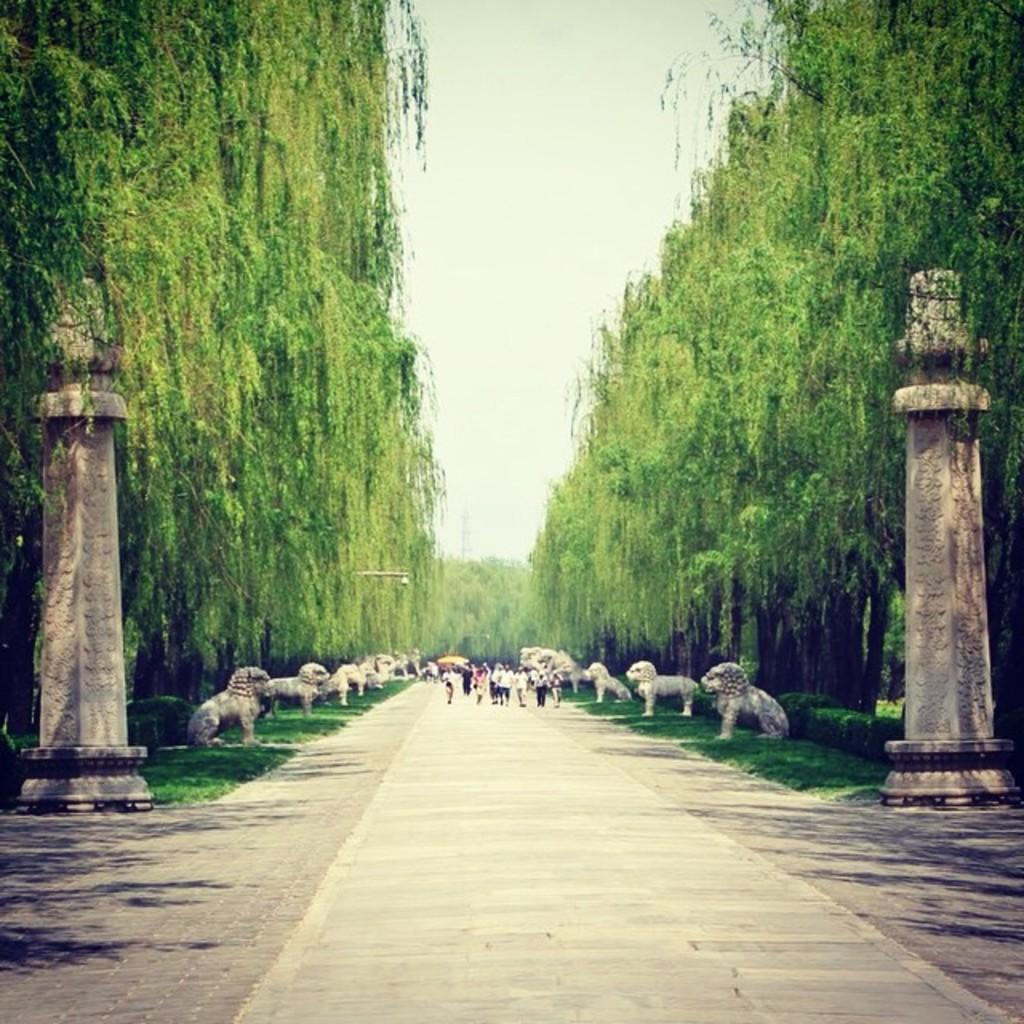How would you summarize this image in a sentence or two? In the image there are few people walking on the road in the middle with statues of either side of it on a grassland followed by trees behind it all over the image with two pillars in the front and above its sky. 